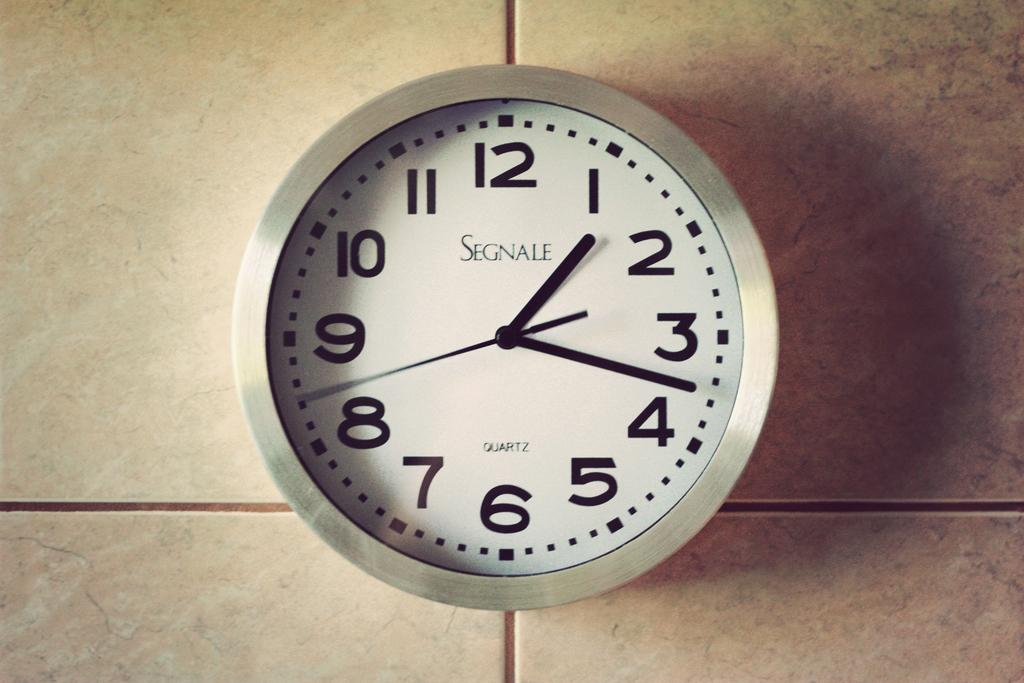<image>
Provide a brief description of the given image. A wall clock by the brand Segnale shows the time is 1:18. 